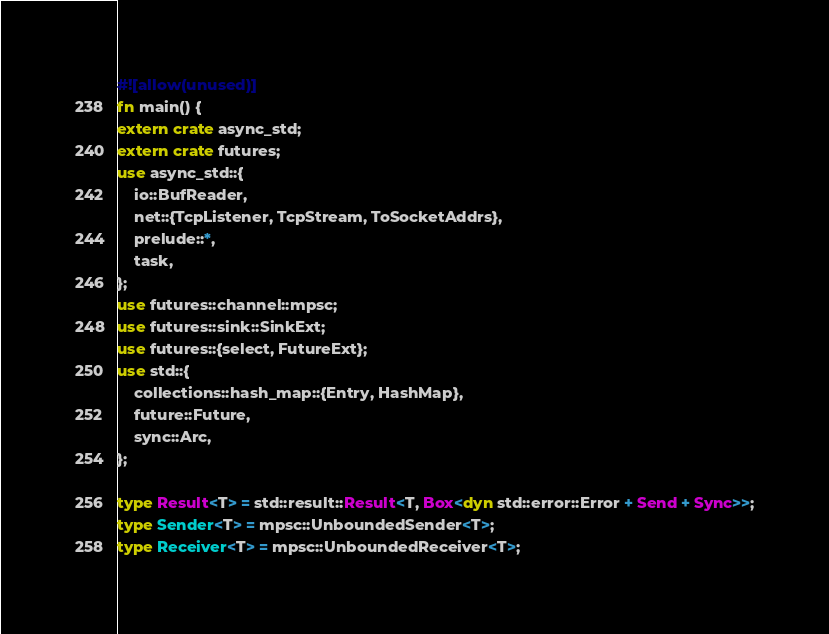<code> <loc_0><loc_0><loc_500><loc_500><_Rust_>
#![allow(unused)]
fn main() {
extern crate async_std;
extern crate futures;
use async_std::{
    io::BufReader,
    net::{TcpListener, TcpStream, ToSocketAddrs},
    prelude::*,
    task,
};
use futures::channel::mpsc;
use futures::sink::SinkExt;
use futures::{select, FutureExt};
use std::{
    collections::hash_map::{Entry, HashMap},
    future::Future,
    sync::Arc,
};

type Result<T> = std::result::Result<T, Box<dyn std::error::Error + Send + Sync>>;
type Sender<T> = mpsc::UnboundedSender<T>;
type Receiver<T> = mpsc::UnboundedReceiver<T>;
</code> 